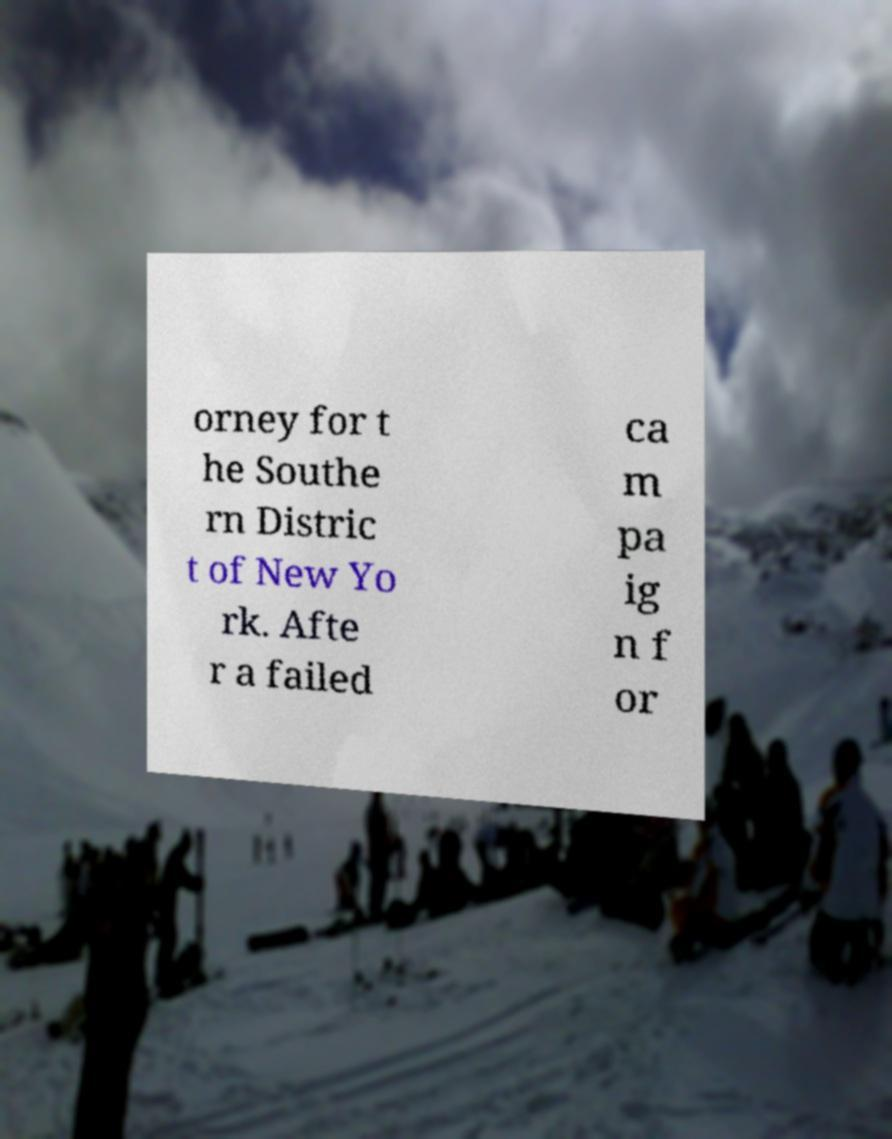Can you read and provide the text displayed in the image?This photo seems to have some interesting text. Can you extract and type it out for me? orney for t he Southe rn Distric t of New Yo rk. Afte r a failed ca m pa ig n f or 